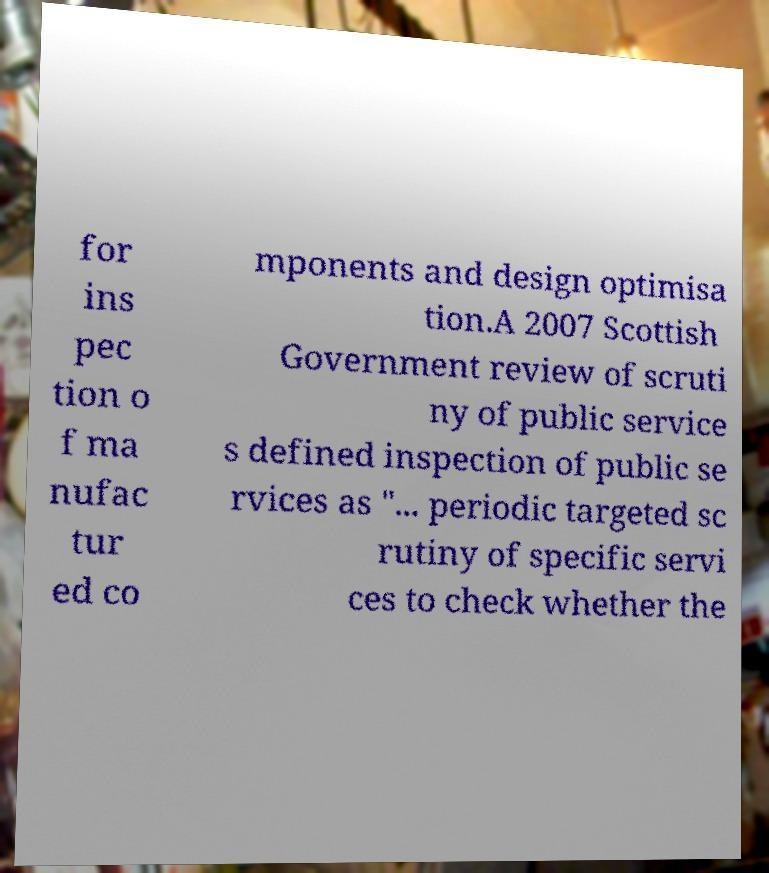Please identify and transcribe the text found in this image. for ins pec tion o f ma nufac tur ed co mponents and design optimisa tion.A 2007 Scottish Government review of scruti ny of public service s defined inspection of public se rvices as "... periodic targeted sc rutiny of specific servi ces to check whether the 